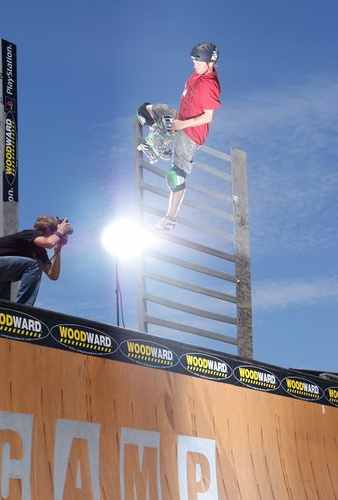Describe the objects in this image and their specific colors. I can see people in blue, lightgray, darkgray, and salmon tones, people in blue, black, gray, and maroon tones, and skateboard in blue, darkgray, lightgray, and lightblue tones in this image. 